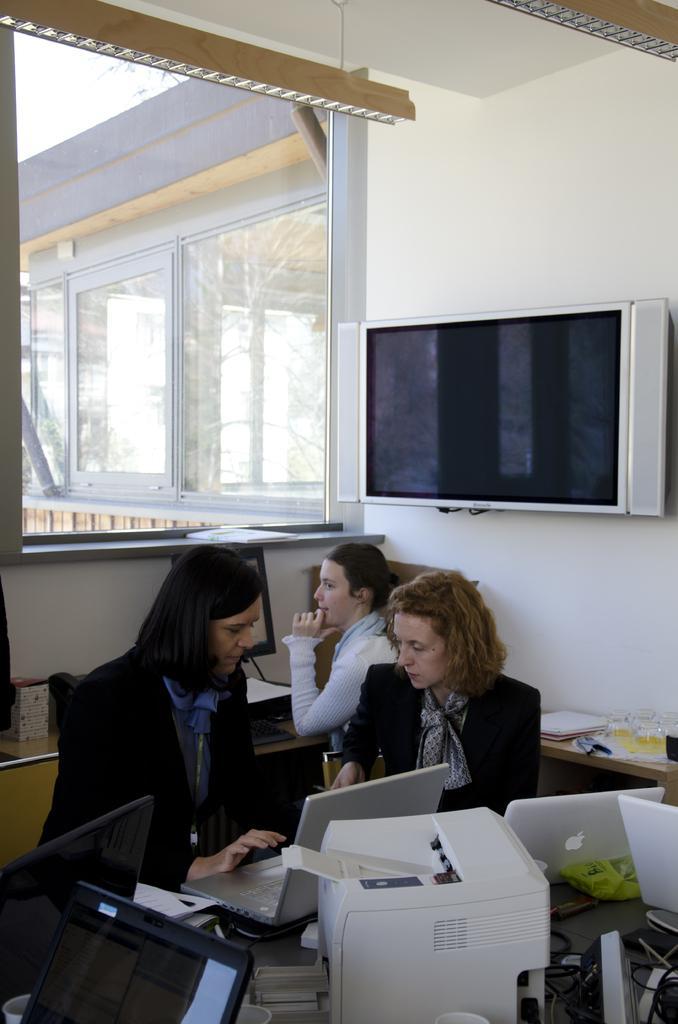Can you describe this image briefly? In this image there are some people who are sitting and there are some tables, on the tables we could see some printers, laptops, computers, wires and some mouses and other objects. And in the center there is one television, on the left side there is a window through the window we could see another window and some plants. 